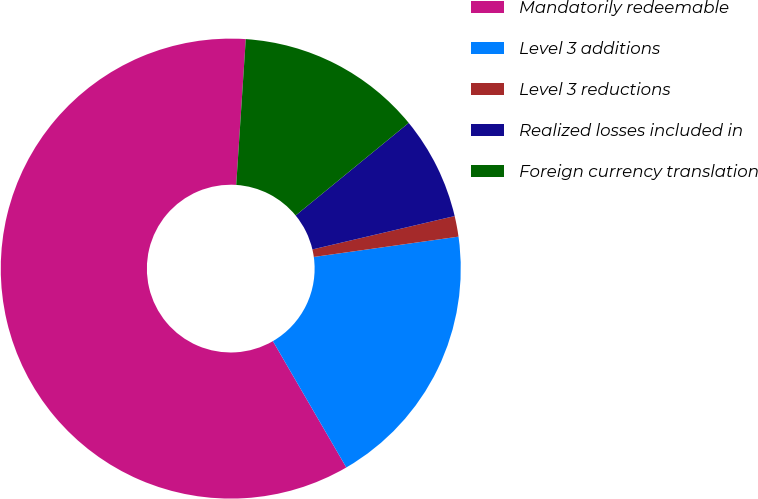Convert chart. <chart><loc_0><loc_0><loc_500><loc_500><pie_chart><fcel>Mandatorily redeemable<fcel>Level 3 additions<fcel>Level 3 reductions<fcel>Realized losses included in<fcel>Foreign currency translation<nl><fcel>59.42%<fcel>18.84%<fcel>1.45%<fcel>7.25%<fcel>13.04%<nl></chart> 